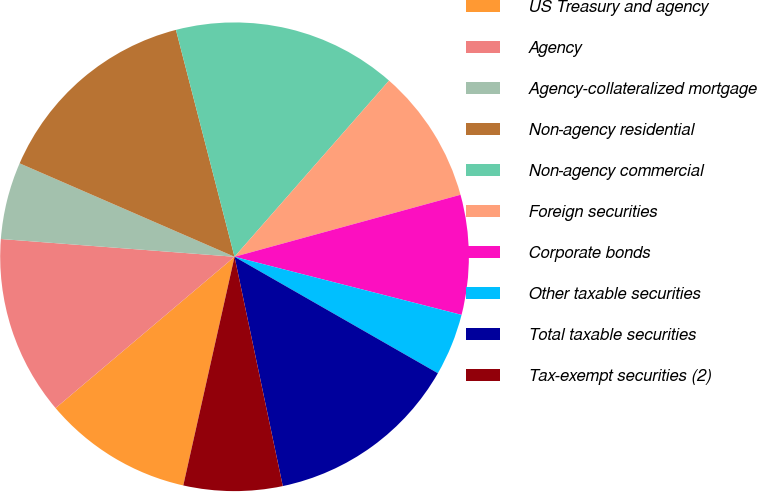Convert chart to OTSL. <chart><loc_0><loc_0><loc_500><loc_500><pie_chart><fcel>US Treasury and agency<fcel>Agency<fcel>Agency-collateralized mortgage<fcel>Non-agency residential<fcel>Non-agency commercial<fcel>Foreign securities<fcel>Corporate bonds<fcel>Other taxable securities<fcel>Total taxable securities<fcel>Tax-exempt securities (2)<nl><fcel>10.32%<fcel>12.38%<fcel>5.32%<fcel>14.45%<fcel>15.48%<fcel>9.28%<fcel>8.25%<fcel>4.29%<fcel>13.42%<fcel>6.81%<nl></chart> 